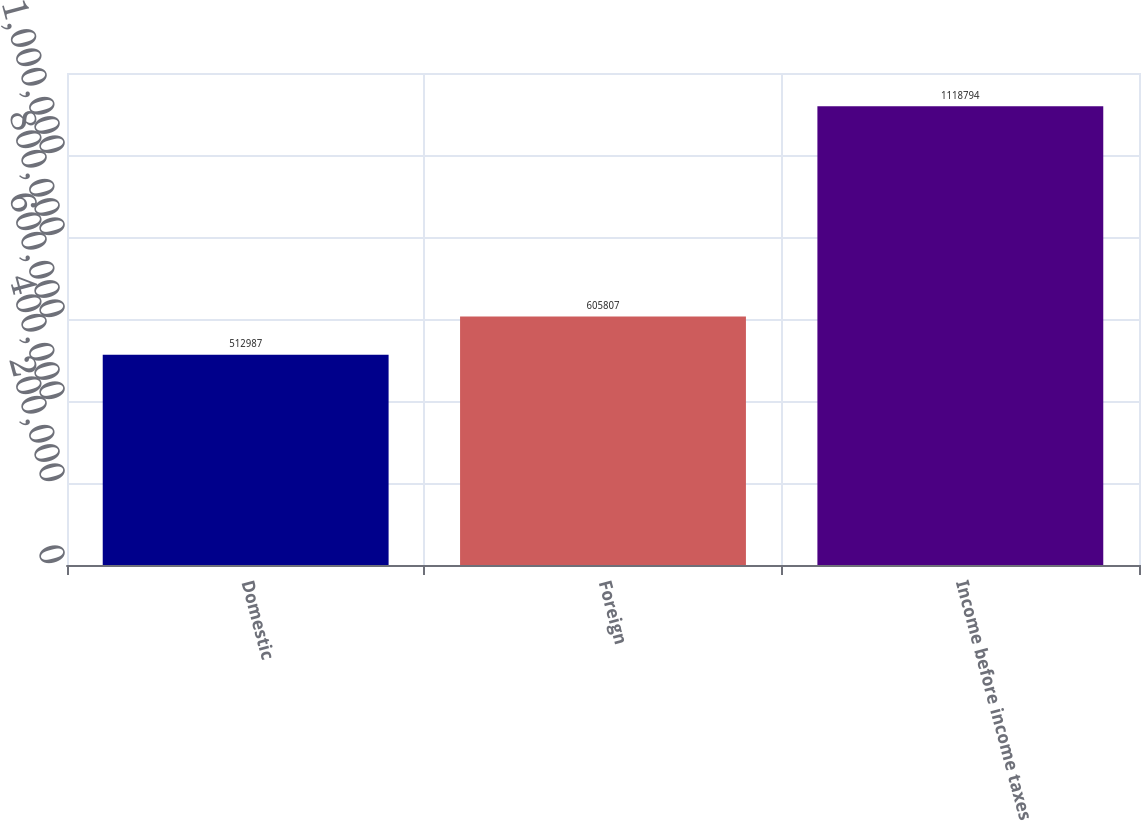Convert chart. <chart><loc_0><loc_0><loc_500><loc_500><bar_chart><fcel>Domestic<fcel>Foreign<fcel>Income before income taxes<nl><fcel>512987<fcel>605807<fcel>1.11879e+06<nl></chart> 